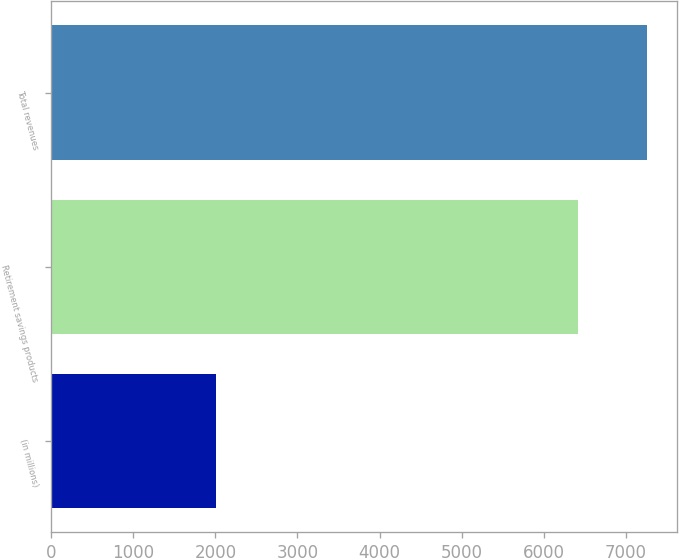Convert chart to OTSL. <chart><loc_0><loc_0><loc_500><loc_500><bar_chart><fcel>(in millions)<fcel>Retirement savings products<fcel>Total revenues<nl><fcel>2012<fcel>6410<fcel>7258<nl></chart> 